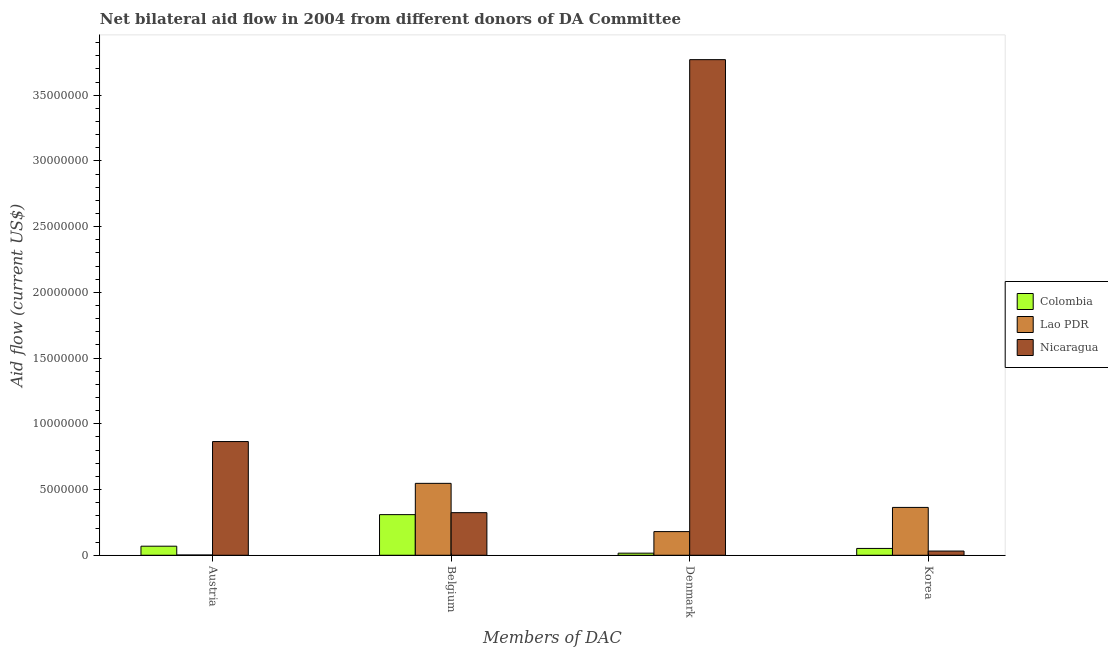How many different coloured bars are there?
Your answer should be compact. 3. How many groups of bars are there?
Give a very brief answer. 4. How many bars are there on the 2nd tick from the left?
Offer a very short reply. 3. How many bars are there on the 1st tick from the right?
Ensure brevity in your answer.  3. What is the label of the 3rd group of bars from the left?
Offer a terse response. Denmark. What is the amount of aid given by austria in Nicaragua?
Give a very brief answer. 8.65e+06. Across all countries, what is the maximum amount of aid given by belgium?
Ensure brevity in your answer.  5.47e+06. Across all countries, what is the minimum amount of aid given by austria?
Offer a very short reply. 2.00e+04. In which country was the amount of aid given by denmark maximum?
Give a very brief answer. Nicaragua. In which country was the amount of aid given by belgium minimum?
Provide a succinct answer. Colombia. What is the total amount of aid given by denmark in the graph?
Offer a terse response. 3.97e+07. What is the difference between the amount of aid given by korea in Colombia and that in Lao PDR?
Provide a short and direct response. -3.12e+06. What is the difference between the amount of aid given by austria in Nicaragua and the amount of aid given by belgium in Lao PDR?
Keep it short and to the point. 3.18e+06. What is the average amount of aid given by austria per country?
Provide a short and direct response. 3.12e+06. What is the difference between the amount of aid given by belgium and amount of aid given by denmark in Lao PDR?
Make the answer very short. 3.67e+06. What is the ratio of the amount of aid given by korea in Nicaragua to that in Lao PDR?
Offer a terse response. 0.09. Is the difference between the amount of aid given by denmark in Colombia and Lao PDR greater than the difference between the amount of aid given by austria in Colombia and Lao PDR?
Provide a succinct answer. No. What is the difference between the highest and the second highest amount of aid given by austria?
Provide a short and direct response. 7.96e+06. What is the difference between the highest and the lowest amount of aid given by belgium?
Your answer should be very brief. 2.38e+06. In how many countries, is the amount of aid given by belgium greater than the average amount of aid given by belgium taken over all countries?
Your response must be concise. 1. Is it the case that in every country, the sum of the amount of aid given by austria and amount of aid given by korea is greater than the sum of amount of aid given by belgium and amount of aid given by denmark?
Ensure brevity in your answer.  Yes. What does the 2nd bar from the left in Austria represents?
Give a very brief answer. Lao PDR. What does the 1st bar from the right in Austria represents?
Offer a terse response. Nicaragua. How many bars are there?
Give a very brief answer. 12. Does the graph contain any zero values?
Provide a short and direct response. No. How many legend labels are there?
Make the answer very short. 3. What is the title of the graph?
Make the answer very short. Net bilateral aid flow in 2004 from different donors of DA Committee. What is the label or title of the X-axis?
Your answer should be compact. Members of DAC. What is the label or title of the Y-axis?
Your response must be concise. Aid flow (current US$). What is the Aid flow (current US$) in Colombia in Austria?
Provide a succinct answer. 6.90e+05. What is the Aid flow (current US$) of Lao PDR in Austria?
Your answer should be very brief. 2.00e+04. What is the Aid flow (current US$) in Nicaragua in Austria?
Your answer should be compact. 8.65e+06. What is the Aid flow (current US$) of Colombia in Belgium?
Offer a very short reply. 3.09e+06. What is the Aid flow (current US$) of Lao PDR in Belgium?
Your answer should be very brief. 5.47e+06. What is the Aid flow (current US$) in Nicaragua in Belgium?
Provide a succinct answer. 3.24e+06. What is the Aid flow (current US$) in Colombia in Denmark?
Provide a short and direct response. 1.60e+05. What is the Aid flow (current US$) of Lao PDR in Denmark?
Give a very brief answer. 1.80e+06. What is the Aid flow (current US$) in Nicaragua in Denmark?
Provide a succinct answer. 3.77e+07. What is the Aid flow (current US$) of Colombia in Korea?
Your answer should be compact. 5.20e+05. What is the Aid flow (current US$) of Lao PDR in Korea?
Provide a succinct answer. 3.64e+06. Across all Members of DAC, what is the maximum Aid flow (current US$) of Colombia?
Your answer should be compact. 3.09e+06. Across all Members of DAC, what is the maximum Aid flow (current US$) in Lao PDR?
Ensure brevity in your answer.  5.47e+06. Across all Members of DAC, what is the maximum Aid flow (current US$) of Nicaragua?
Your answer should be compact. 3.77e+07. Across all Members of DAC, what is the minimum Aid flow (current US$) of Colombia?
Provide a succinct answer. 1.60e+05. Across all Members of DAC, what is the minimum Aid flow (current US$) in Lao PDR?
Your answer should be compact. 2.00e+04. What is the total Aid flow (current US$) in Colombia in the graph?
Provide a short and direct response. 4.46e+06. What is the total Aid flow (current US$) in Lao PDR in the graph?
Make the answer very short. 1.09e+07. What is the total Aid flow (current US$) in Nicaragua in the graph?
Offer a terse response. 4.99e+07. What is the difference between the Aid flow (current US$) in Colombia in Austria and that in Belgium?
Your response must be concise. -2.40e+06. What is the difference between the Aid flow (current US$) of Lao PDR in Austria and that in Belgium?
Your answer should be very brief. -5.45e+06. What is the difference between the Aid flow (current US$) of Nicaragua in Austria and that in Belgium?
Make the answer very short. 5.41e+06. What is the difference between the Aid flow (current US$) in Colombia in Austria and that in Denmark?
Your response must be concise. 5.30e+05. What is the difference between the Aid flow (current US$) in Lao PDR in Austria and that in Denmark?
Offer a very short reply. -1.78e+06. What is the difference between the Aid flow (current US$) of Nicaragua in Austria and that in Denmark?
Provide a succinct answer. -2.90e+07. What is the difference between the Aid flow (current US$) in Colombia in Austria and that in Korea?
Offer a terse response. 1.70e+05. What is the difference between the Aid flow (current US$) of Lao PDR in Austria and that in Korea?
Provide a short and direct response. -3.62e+06. What is the difference between the Aid flow (current US$) of Nicaragua in Austria and that in Korea?
Your response must be concise. 8.33e+06. What is the difference between the Aid flow (current US$) of Colombia in Belgium and that in Denmark?
Your answer should be compact. 2.93e+06. What is the difference between the Aid flow (current US$) in Lao PDR in Belgium and that in Denmark?
Your answer should be compact. 3.67e+06. What is the difference between the Aid flow (current US$) of Nicaragua in Belgium and that in Denmark?
Keep it short and to the point. -3.45e+07. What is the difference between the Aid flow (current US$) of Colombia in Belgium and that in Korea?
Make the answer very short. 2.57e+06. What is the difference between the Aid flow (current US$) in Lao PDR in Belgium and that in Korea?
Give a very brief answer. 1.83e+06. What is the difference between the Aid flow (current US$) of Nicaragua in Belgium and that in Korea?
Keep it short and to the point. 2.92e+06. What is the difference between the Aid flow (current US$) of Colombia in Denmark and that in Korea?
Make the answer very short. -3.60e+05. What is the difference between the Aid flow (current US$) of Lao PDR in Denmark and that in Korea?
Your response must be concise. -1.84e+06. What is the difference between the Aid flow (current US$) in Nicaragua in Denmark and that in Korea?
Provide a short and direct response. 3.74e+07. What is the difference between the Aid flow (current US$) of Colombia in Austria and the Aid flow (current US$) of Lao PDR in Belgium?
Your response must be concise. -4.78e+06. What is the difference between the Aid flow (current US$) of Colombia in Austria and the Aid flow (current US$) of Nicaragua in Belgium?
Your response must be concise. -2.55e+06. What is the difference between the Aid flow (current US$) of Lao PDR in Austria and the Aid flow (current US$) of Nicaragua in Belgium?
Offer a very short reply. -3.22e+06. What is the difference between the Aid flow (current US$) of Colombia in Austria and the Aid flow (current US$) of Lao PDR in Denmark?
Offer a very short reply. -1.11e+06. What is the difference between the Aid flow (current US$) of Colombia in Austria and the Aid flow (current US$) of Nicaragua in Denmark?
Ensure brevity in your answer.  -3.70e+07. What is the difference between the Aid flow (current US$) in Lao PDR in Austria and the Aid flow (current US$) in Nicaragua in Denmark?
Provide a short and direct response. -3.77e+07. What is the difference between the Aid flow (current US$) of Colombia in Austria and the Aid flow (current US$) of Lao PDR in Korea?
Give a very brief answer. -2.95e+06. What is the difference between the Aid flow (current US$) in Lao PDR in Austria and the Aid flow (current US$) in Nicaragua in Korea?
Ensure brevity in your answer.  -3.00e+05. What is the difference between the Aid flow (current US$) of Colombia in Belgium and the Aid flow (current US$) of Lao PDR in Denmark?
Make the answer very short. 1.29e+06. What is the difference between the Aid flow (current US$) in Colombia in Belgium and the Aid flow (current US$) in Nicaragua in Denmark?
Your response must be concise. -3.46e+07. What is the difference between the Aid flow (current US$) in Lao PDR in Belgium and the Aid flow (current US$) in Nicaragua in Denmark?
Keep it short and to the point. -3.22e+07. What is the difference between the Aid flow (current US$) in Colombia in Belgium and the Aid flow (current US$) in Lao PDR in Korea?
Give a very brief answer. -5.50e+05. What is the difference between the Aid flow (current US$) of Colombia in Belgium and the Aid flow (current US$) of Nicaragua in Korea?
Offer a terse response. 2.77e+06. What is the difference between the Aid flow (current US$) in Lao PDR in Belgium and the Aid flow (current US$) in Nicaragua in Korea?
Ensure brevity in your answer.  5.15e+06. What is the difference between the Aid flow (current US$) of Colombia in Denmark and the Aid flow (current US$) of Lao PDR in Korea?
Provide a short and direct response. -3.48e+06. What is the difference between the Aid flow (current US$) of Lao PDR in Denmark and the Aid flow (current US$) of Nicaragua in Korea?
Provide a short and direct response. 1.48e+06. What is the average Aid flow (current US$) of Colombia per Members of DAC?
Give a very brief answer. 1.12e+06. What is the average Aid flow (current US$) of Lao PDR per Members of DAC?
Make the answer very short. 2.73e+06. What is the average Aid flow (current US$) in Nicaragua per Members of DAC?
Your response must be concise. 1.25e+07. What is the difference between the Aid flow (current US$) of Colombia and Aid flow (current US$) of Lao PDR in Austria?
Your answer should be very brief. 6.70e+05. What is the difference between the Aid flow (current US$) of Colombia and Aid flow (current US$) of Nicaragua in Austria?
Provide a succinct answer. -7.96e+06. What is the difference between the Aid flow (current US$) in Lao PDR and Aid flow (current US$) in Nicaragua in Austria?
Keep it short and to the point. -8.63e+06. What is the difference between the Aid flow (current US$) in Colombia and Aid flow (current US$) in Lao PDR in Belgium?
Offer a terse response. -2.38e+06. What is the difference between the Aid flow (current US$) in Lao PDR and Aid flow (current US$) in Nicaragua in Belgium?
Keep it short and to the point. 2.23e+06. What is the difference between the Aid flow (current US$) in Colombia and Aid flow (current US$) in Lao PDR in Denmark?
Your answer should be very brief. -1.64e+06. What is the difference between the Aid flow (current US$) of Colombia and Aid flow (current US$) of Nicaragua in Denmark?
Offer a very short reply. -3.75e+07. What is the difference between the Aid flow (current US$) in Lao PDR and Aid flow (current US$) in Nicaragua in Denmark?
Make the answer very short. -3.59e+07. What is the difference between the Aid flow (current US$) in Colombia and Aid flow (current US$) in Lao PDR in Korea?
Offer a very short reply. -3.12e+06. What is the difference between the Aid flow (current US$) in Colombia and Aid flow (current US$) in Nicaragua in Korea?
Make the answer very short. 2.00e+05. What is the difference between the Aid flow (current US$) in Lao PDR and Aid flow (current US$) in Nicaragua in Korea?
Provide a succinct answer. 3.32e+06. What is the ratio of the Aid flow (current US$) in Colombia in Austria to that in Belgium?
Provide a short and direct response. 0.22. What is the ratio of the Aid flow (current US$) in Lao PDR in Austria to that in Belgium?
Offer a very short reply. 0. What is the ratio of the Aid flow (current US$) in Nicaragua in Austria to that in Belgium?
Keep it short and to the point. 2.67. What is the ratio of the Aid flow (current US$) of Colombia in Austria to that in Denmark?
Your response must be concise. 4.31. What is the ratio of the Aid flow (current US$) of Lao PDR in Austria to that in Denmark?
Provide a succinct answer. 0.01. What is the ratio of the Aid flow (current US$) in Nicaragua in Austria to that in Denmark?
Provide a succinct answer. 0.23. What is the ratio of the Aid flow (current US$) of Colombia in Austria to that in Korea?
Provide a succinct answer. 1.33. What is the ratio of the Aid flow (current US$) in Lao PDR in Austria to that in Korea?
Your answer should be very brief. 0.01. What is the ratio of the Aid flow (current US$) in Nicaragua in Austria to that in Korea?
Ensure brevity in your answer.  27.03. What is the ratio of the Aid flow (current US$) of Colombia in Belgium to that in Denmark?
Your answer should be very brief. 19.31. What is the ratio of the Aid flow (current US$) in Lao PDR in Belgium to that in Denmark?
Provide a succinct answer. 3.04. What is the ratio of the Aid flow (current US$) of Nicaragua in Belgium to that in Denmark?
Make the answer very short. 0.09. What is the ratio of the Aid flow (current US$) of Colombia in Belgium to that in Korea?
Provide a succinct answer. 5.94. What is the ratio of the Aid flow (current US$) in Lao PDR in Belgium to that in Korea?
Your response must be concise. 1.5. What is the ratio of the Aid flow (current US$) of Nicaragua in Belgium to that in Korea?
Your answer should be compact. 10.12. What is the ratio of the Aid flow (current US$) in Colombia in Denmark to that in Korea?
Provide a short and direct response. 0.31. What is the ratio of the Aid flow (current US$) in Lao PDR in Denmark to that in Korea?
Offer a terse response. 0.49. What is the ratio of the Aid flow (current US$) of Nicaragua in Denmark to that in Korea?
Your answer should be very brief. 117.81. What is the difference between the highest and the second highest Aid flow (current US$) in Colombia?
Ensure brevity in your answer.  2.40e+06. What is the difference between the highest and the second highest Aid flow (current US$) of Lao PDR?
Offer a terse response. 1.83e+06. What is the difference between the highest and the second highest Aid flow (current US$) of Nicaragua?
Your answer should be very brief. 2.90e+07. What is the difference between the highest and the lowest Aid flow (current US$) in Colombia?
Ensure brevity in your answer.  2.93e+06. What is the difference between the highest and the lowest Aid flow (current US$) in Lao PDR?
Provide a short and direct response. 5.45e+06. What is the difference between the highest and the lowest Aid flow (current US$) of Nicaragua?
Ensure brevity in your answer.  3.74e+07. 